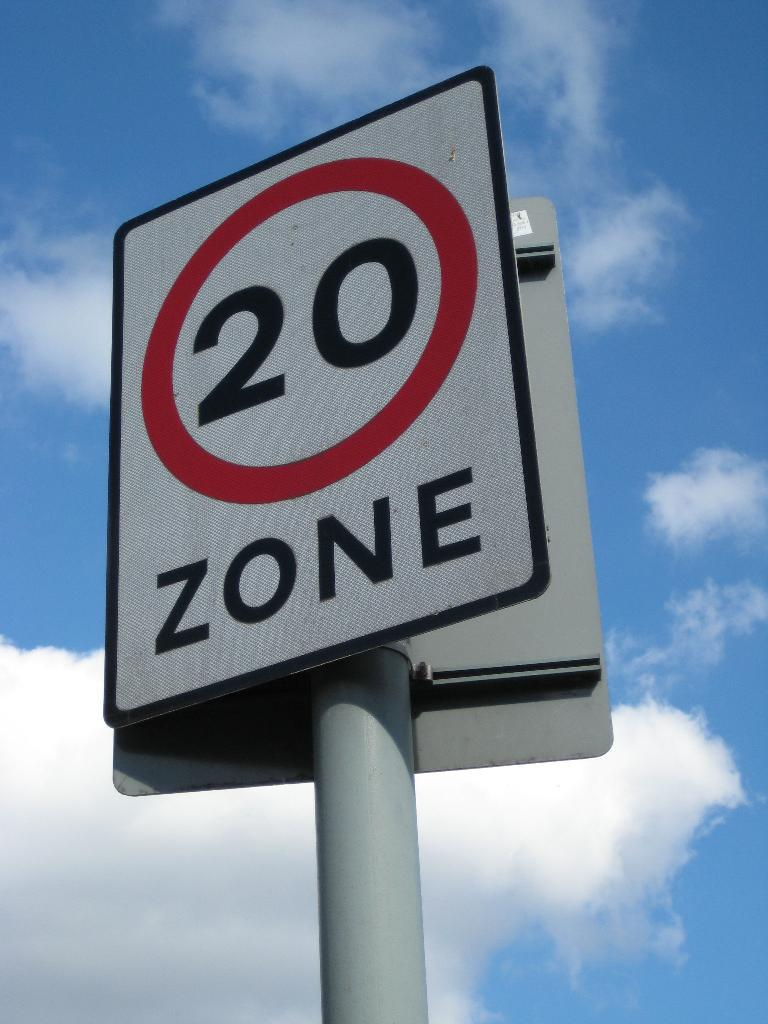<image>
Relay a brief, clear account of the picture shown. The sign has the number 20 in a red circle with the word ZONE written under it. 